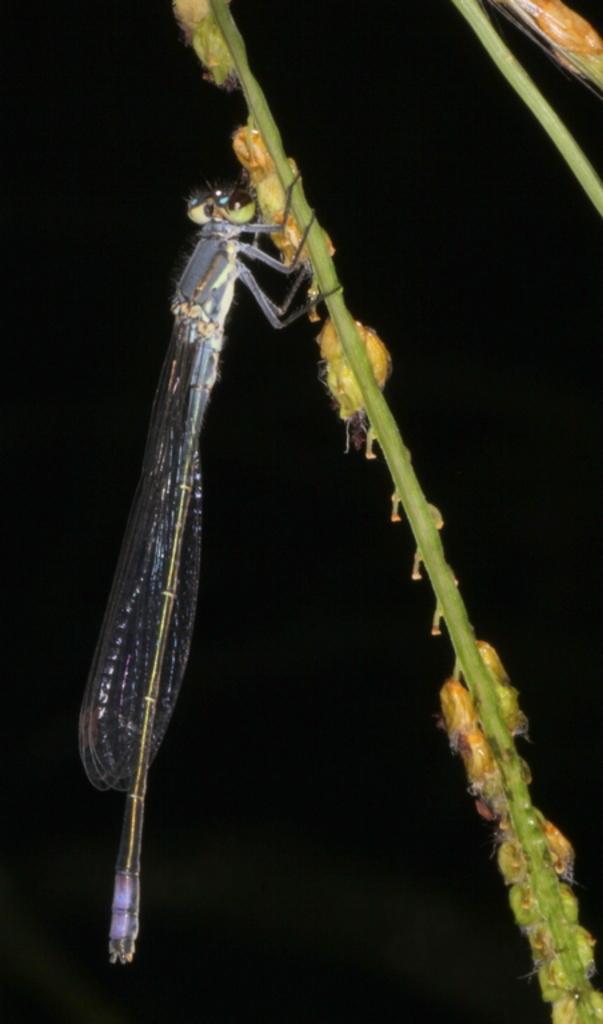Could you give a brief overview of what you see in this image? In this image we can see a dragonfly on a stem with grains. In the background it is dark. 